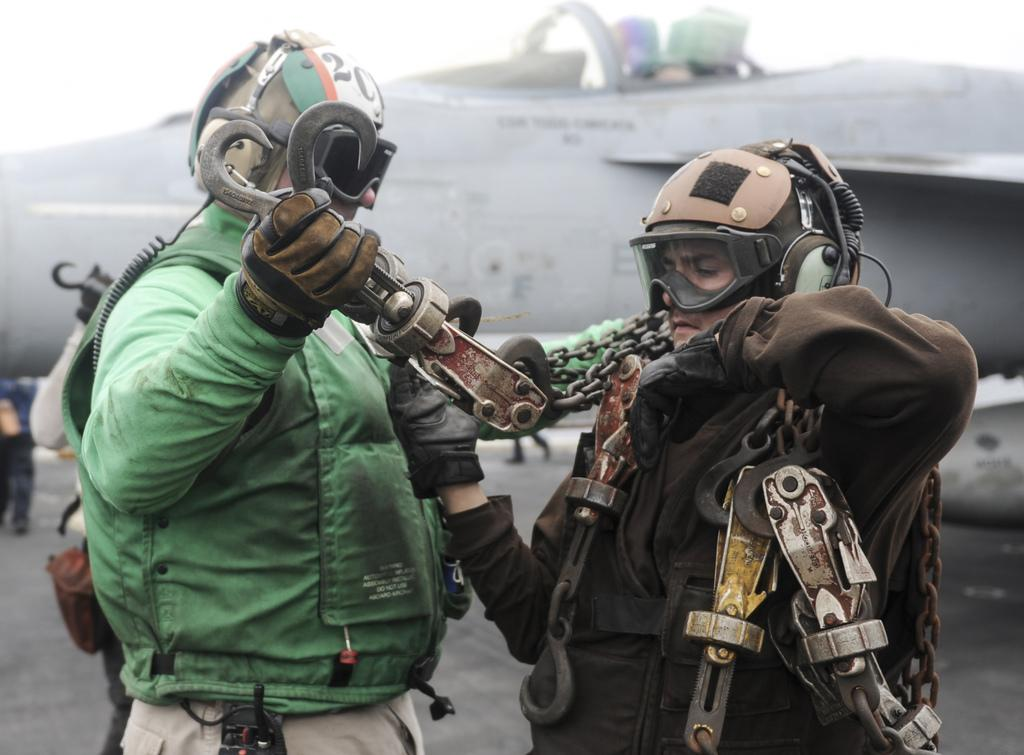How many people are in the image? There are two men in the image. What are the men wearing? The men are wearing jackets. What are the men carrying? The men are carrying different objects. What can be seen in the background of the image? There is a flight visible in the background of the image. What type of glue is being used by the men in the image? There is no glue present in the image, and the men are not using any glue. Can you tell me how long the church has been in the image? There is no church present in the image, so it is not possible to determine how long it has been there. 